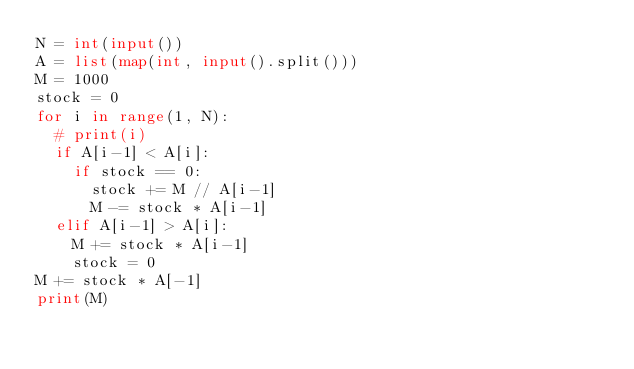<code> <loc_0><loc_0><loc_500><loc_500><_Python_>N = int(input())
A = list(map(int, input().split()))
M = 1000
stock = 0
for i in range(1, N):
  # print(i)
  if A[i-1] < A[i]:
    if stock == 0:
      stock += M // A[i-1]
      M -= stock * A[i-1]
  elif A[i-1] > A[i]:
    M += stock * A[i-1]
    stock = 0
M += stock * A[-1]
print(M)</code> 